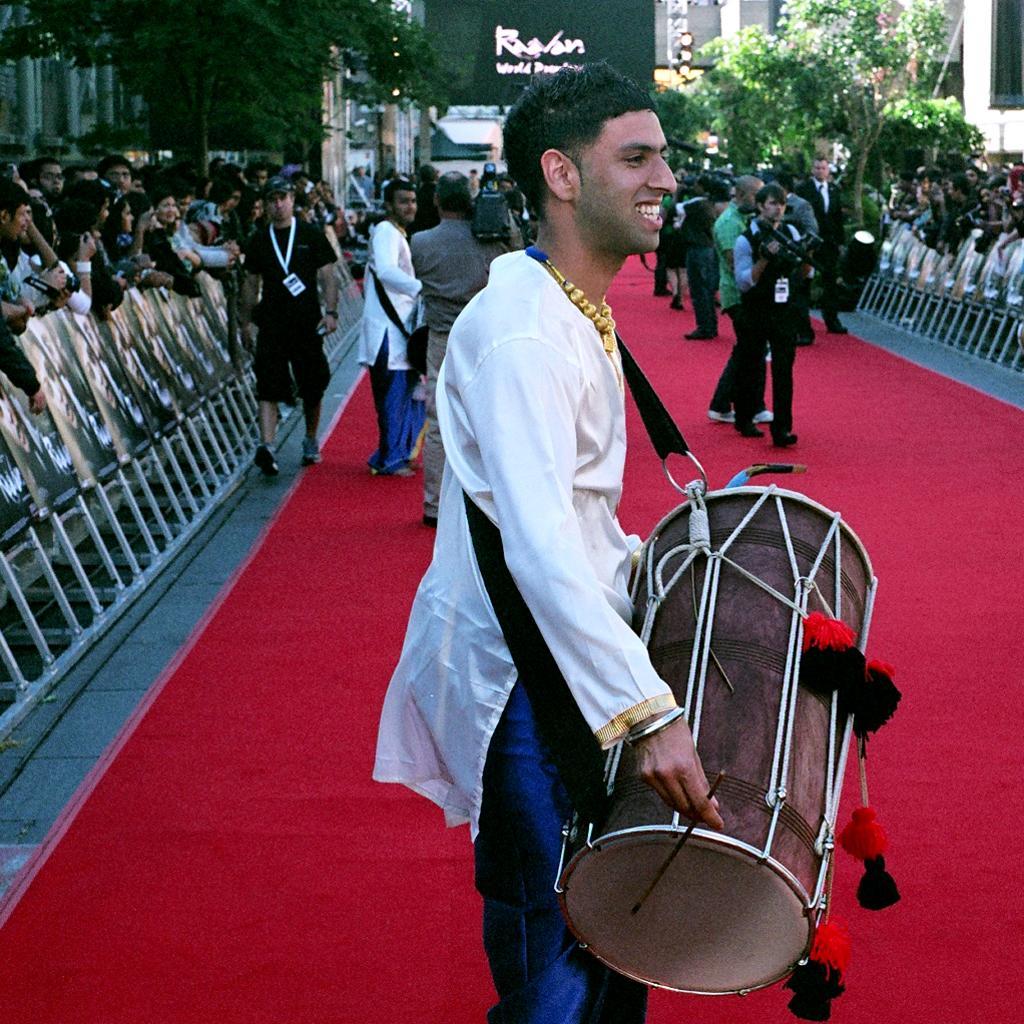Can you describe this image briefly? At the left and right side of the picture we can see a crowd. These are trees. Here on the red carpet we can see few persons walking and recording by holding a camera in his hand and one man is playing drums. 